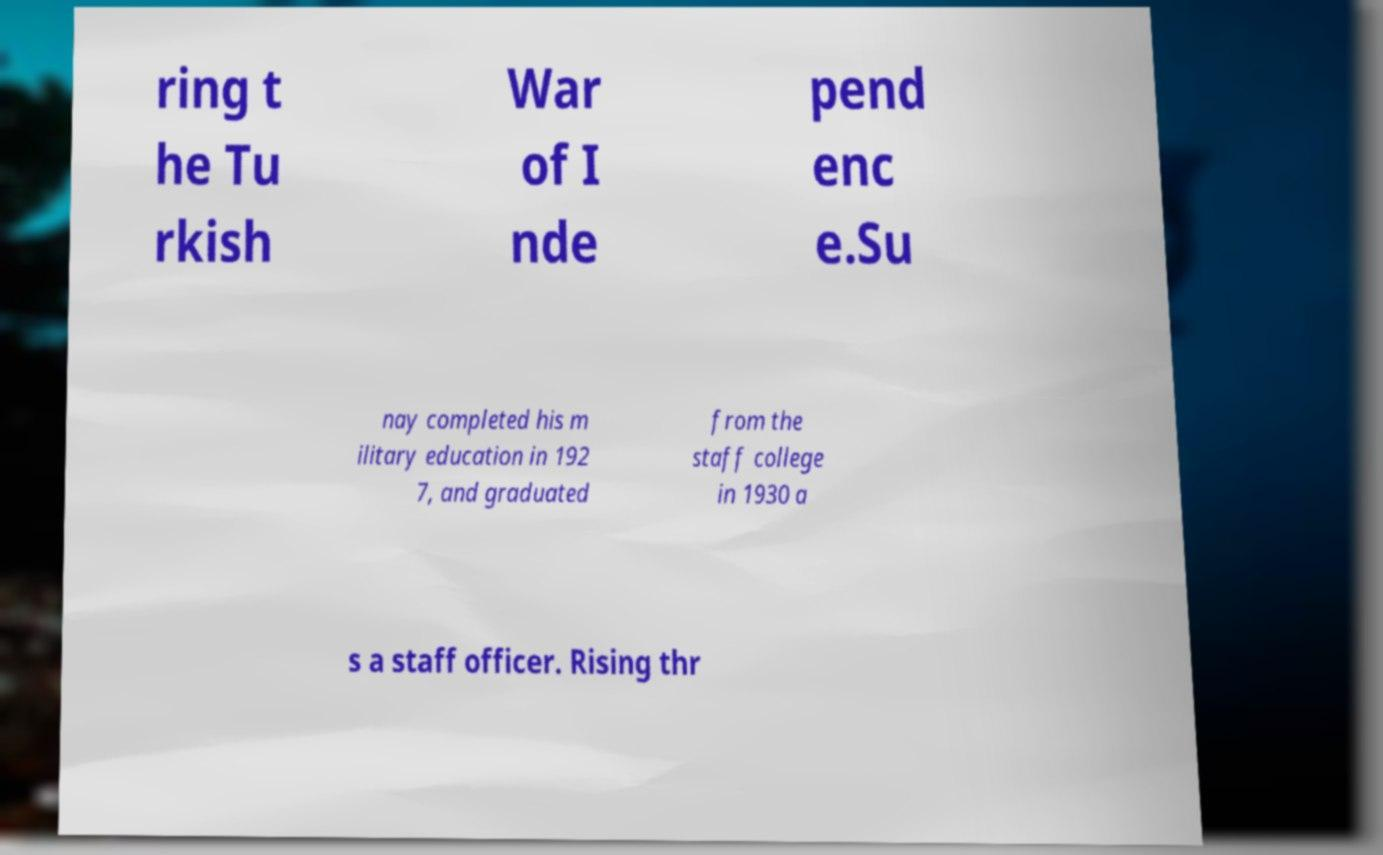What messages or text are displayed in this image? I need them in a readable, typed format. ring t he Tu rkish War of I nde pend enc e.Su nay completed his m ilitary education in 192 7, and graduated from the staff college in 1930 a s a staff officer. Rising thr 